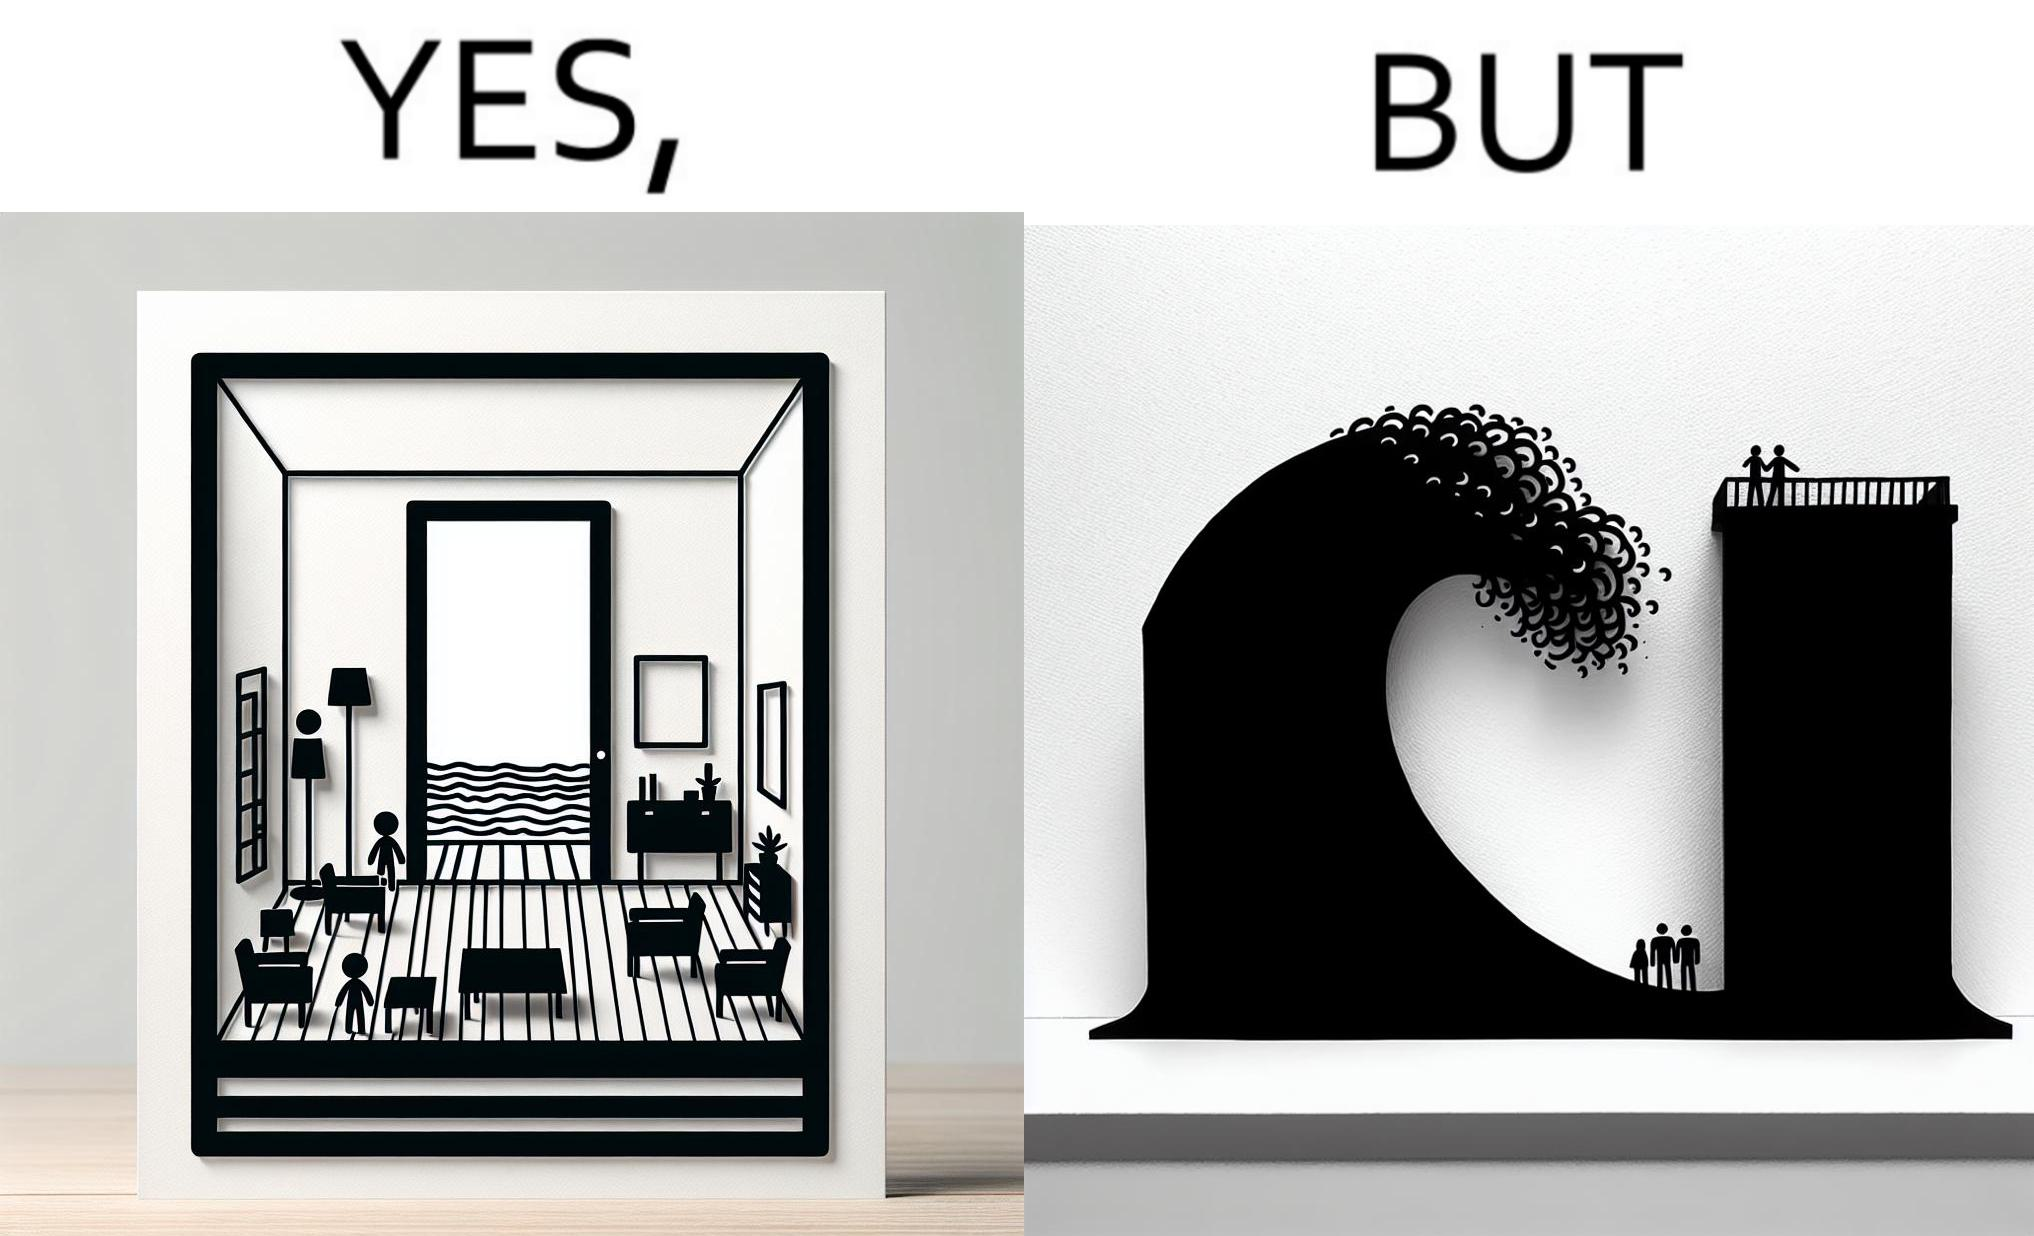Explain why this image is satirical. The same sea which gives us a relaxation on a normal day can pose a danger to us sometimes like during a tsunami 